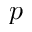<formula> <loc_0><loc_0><loc_500><loc_500>p</formula> 